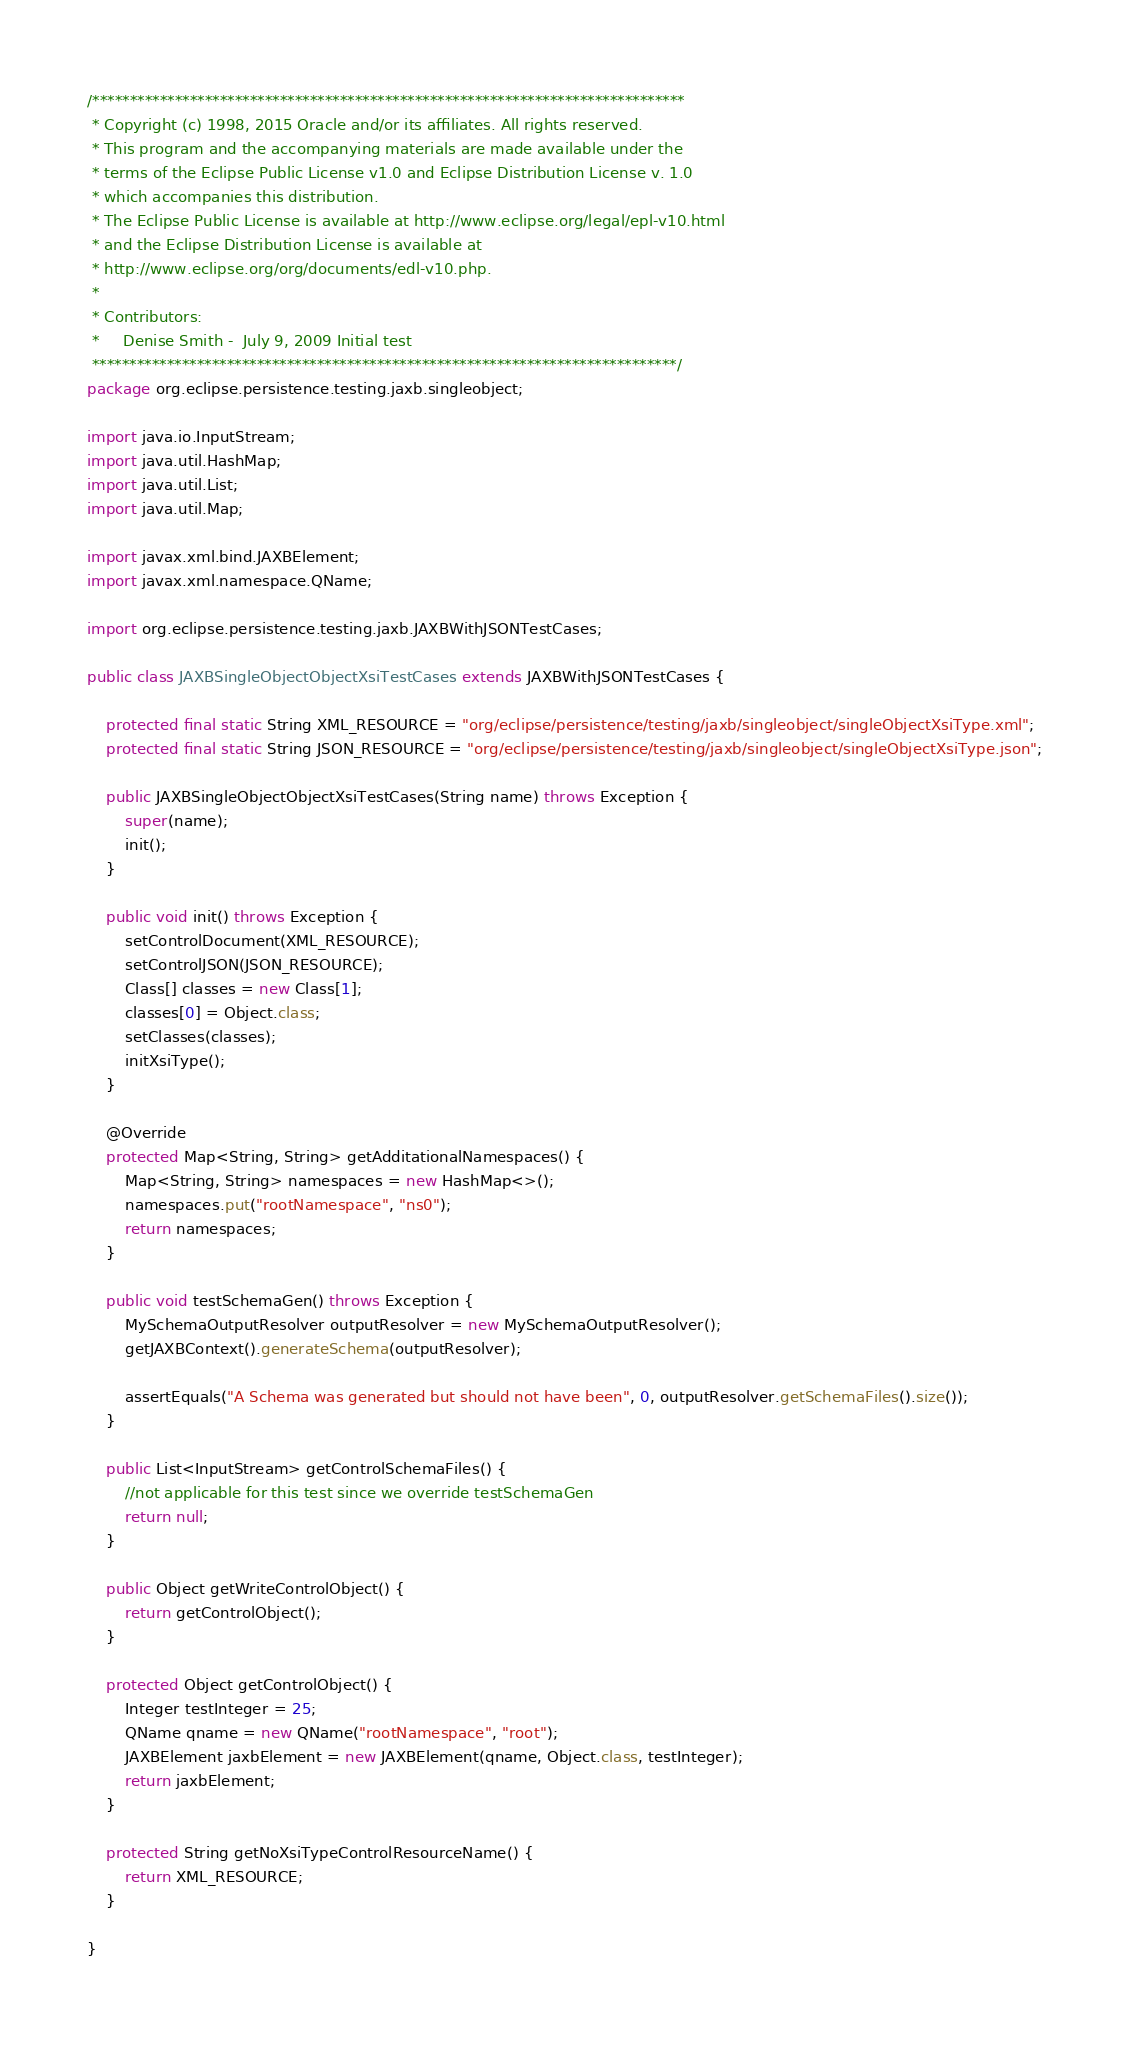Convert code to text. <code><loc_0><loc_0><loc_500><loc_500><_Java_>/*******************************************************************************
 * Copyright (c) 1998, 2015 Oracle and/or its affiliates. All rights reserved.
 * This program and the accompanying materials are made available under the
 * terms of the Eclipse Public License v1.0 and Eclipse Distribution License v. 1.0
 * which accompanies this distribution.
 * The Eclipse Public License is available at http://www.eclipse.org/legal/epl-v10.html
 * and the Eclipse Distribution License is available at
 * http://www.eclipse.org/org/documents/edl-v10.php.
 *
 * Contributors:
 *     Denise Smith -  July 9, 2009 Initial test
 ******************************************************************************/
package org.eclipse.persistence.testing.jaxb.singleobject;

import java.io.InputStream;
import java.util.HashMap;
import java.util.List;
import java.util.Map;

import javax.xml.bind.JAXBElement;
import javax.xml.namespace.QName;

import org.eclipse.persistence.testing.jaxb.JAXBWithJSONTestCases;

public class JAXBSingleObjectObjectXsiTestCases extends JAXBWithJSONTestCases {

    protected final static String XML_RESOURCE = "org/eclipse/persistence/testing/jaxb/singleobject/singleObjectXsiType.xml";
    protected final static String JSON_RESOURCE = "org/eclipse/persistence/testing/jaxb/singleobject/singleObjectXsiType.json";

    public JAXBSingleObjectObjectXsiTestCases(String name) throws Exception {
        super(name);
        init();
    }

    public void init() throws Exception {
        setControlDocument(XML_RESOURCE);
        setControlJSON(JSON_RESOURCE);
        Class[] classes = new Class[1];
        classes[0] = Object.class;
        setClasses(classes);
        initXsiType();
    }

    @Override
    protected Map<String, String> getAdditationalNamespaces() {
        Map<String, String> namespaces = new HashMap<>();
        namespaces.put("rootNamespace", "ns0");
        return namespaces;
    }

    public void testSchemaGen() throws Exception {
        MySchemaOutputResolver outputResolver = new MySchemaOutputResolver();
        getJAXBContext().generateSchema(outputResolver);

        assertEquals("A Schema was generated but should not have been", 0, outputResolver.getSchemaFiles().size());
    }

    public List<InputStream> getControlSchemaFiles() {
        //not applicable for this test since we override testSchemaGen
        return null;
    }

    public Object getWriteControlObject() {
        return getControlObject();
    }

    protected Object getControlObject() {
        Integer testInteger = 25;
        QName qname = new QName("rootNamespace", "root");
        JAXBElement jaxbElement = new JAXBElement(qname, Object.class, testInteger);
        return jaxbElement;
    }

    protected String getNoXsiTypeControlResourceName() {
        return XML_RESOURCE;
    }

}
</code> 